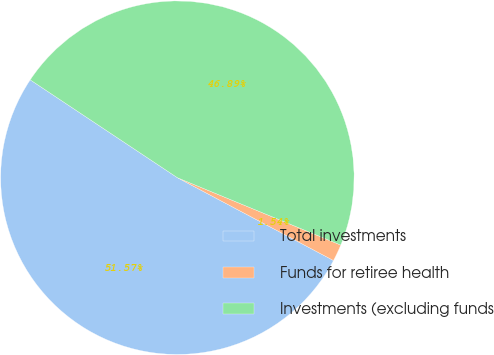<chart> <loc_0><loc_0><loc_500><loc_500><pie_chart><fcel>Total investments<fcel>Funds for retiree health<fcel>Investments (excluding funds<nl><fcel>51.58%<fcel>1.54%<fcel>46.89%<nl></chart> 